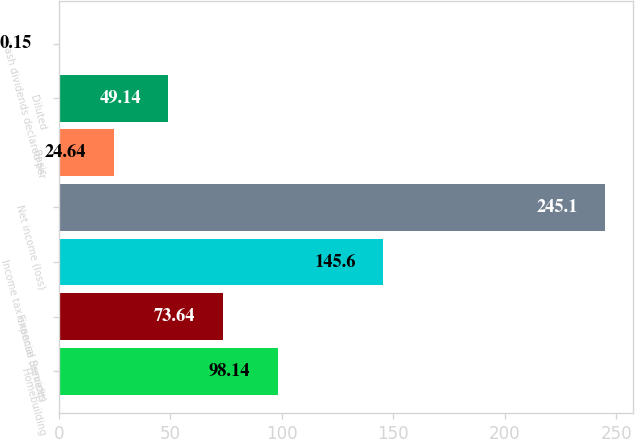Convert chart. <chart><loc_0><loc_0><loc_500><loc_500><bar_chart><fcel>Homebuilding<fcel>Financial Services<fcel>Income tax expense (benefit)<fcel>Net income (loss)<fcel>Basic<fcel>Diluted<fcel>Cash dividends declared per<nl><fcel>98.14<fcel>73.64<fcel>145.6<fcel>245.1<fcel>24.64<fcel>49.14<fcel>0.15<nl></chart> 